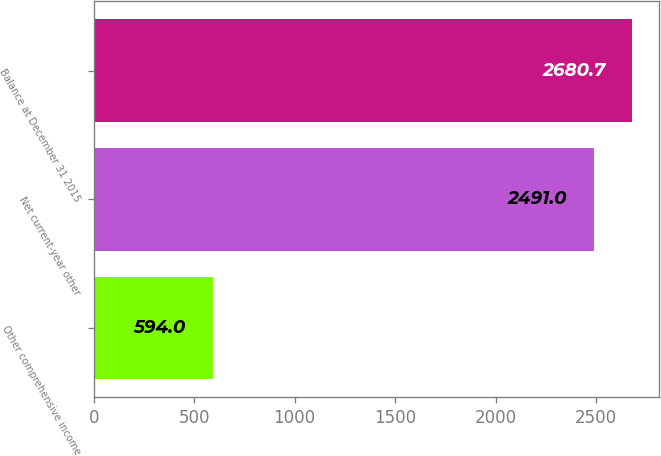Convert chart to OTSL. <chart><loc_0><loc_0><loc_500><loc_500><bar_chart><fcel>Other comprehensive income<fcel>Net current-year other<fcel>Balance at December 31 2015<nl><fcel>594<fcel>2491<fcel>2680.7<nl></chart> 